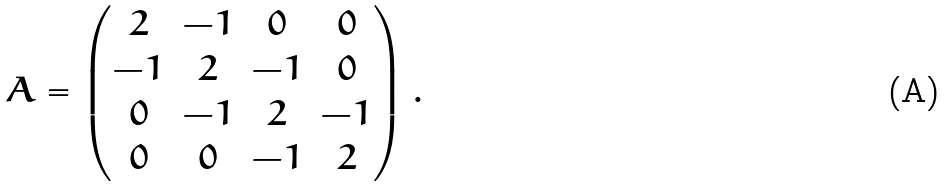Convert formula to latex. <formula><loc_0><loc_0><loc_500><loc_500>A = \begin{pmatrix} 2 & - 1 & 0 & 0 \\ - 1 & 2 & - 1 & 0 \\ 0 & - 1 & 2 & - 1 \\ 0 & 0 & - 1 & 2 \end{pmatrix} .</formula> 